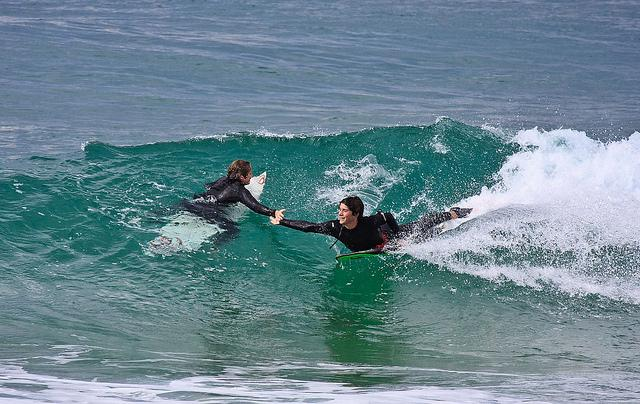What are the people holding? hands 